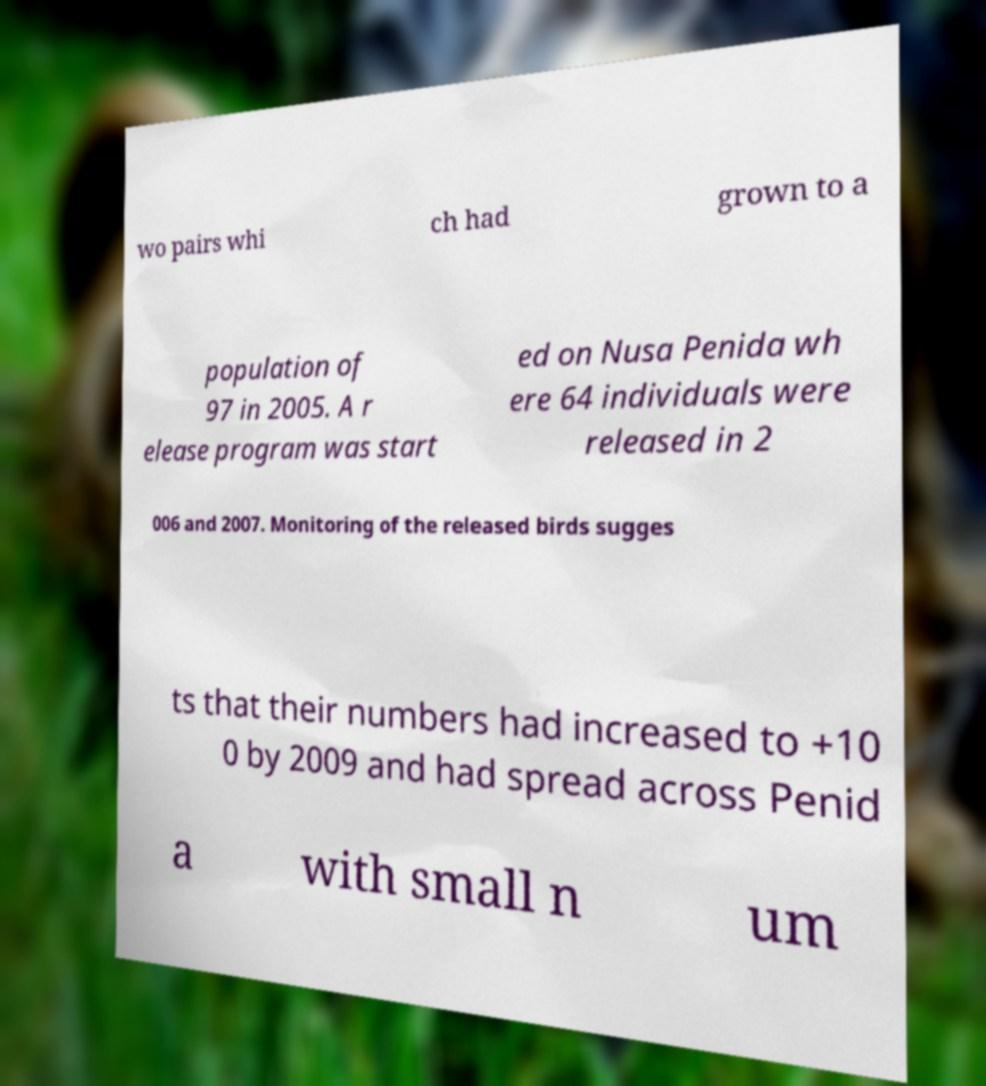What messages or text are displayed in this image? I need them in a readable, typed format. wo pairs whi ch had grown to a population of 97 in 2005. A r elease program was start ed on Nusa Penida wh ere 64 individuals were released in 2 006 and 2007. Monitoring of the released birds sugges ts that their numbers had increased to +10 0 by 2009 and had spread across Penid a with small n um 